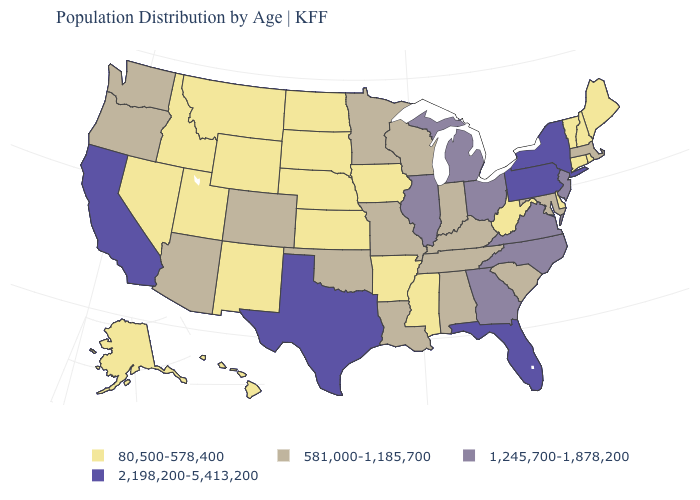Name the states that have a value in the range 581,000-1,185,700?
Give a very brief answer. Alabama, Arizona, Colorado, Indiana, Kentucky, Louisiana, Maryland, Massachusetts, Minnesota, Missouri, Oklahoma, Oregon, South Carolina, Tennessee, Washington, Wisconsin. What is the value of South Dakota?
Quick response, please. 80,500-578,400. Is the legend a continuous bar?
Answer briefly. No. Among the states that border Louisiana , does Arkansas have the lowest value?
Write a very short answer. Yes. Does Ohio have the highest value in the USA?
Answer briefly. No. Among the states that border North Dakota , does Minnesota have the highest value?
Give a very brief answer. Yes. Which states hav the highest value in the Northeast?
Concise answer only. New York, Pennsylvania. Does Georgia have the highest value in the South?
Concise answer only. No. Does Idaho have a lower value than Georgia?
Be succinct. Yes. What is the value of North Dakota?
Keep it brief. 80,500-578,400. Name the states that have a value in the range 581,000-1,185,700?
Write a very short answer. Alabama, Arizona, Colorado, Indiana, Kentucky, Louisiana, Maryland, Massachusetts, Minnesota, Missouri, Oklahoma, Oregon, South Carolina, Tennessee, Washington, Wisconsin. Does North Carolina have the lowest value in the USA?
Answer briefly. No. What is the highest value in states that border Massachusetts?
Concise answer only. 2,198,200-5,413,200. Does the first symbol in the legend represent the smallest category?
Quick response, please. Yes. What is the value of Illinois?
Keep it brief. 1,245,700-1,878,200. 